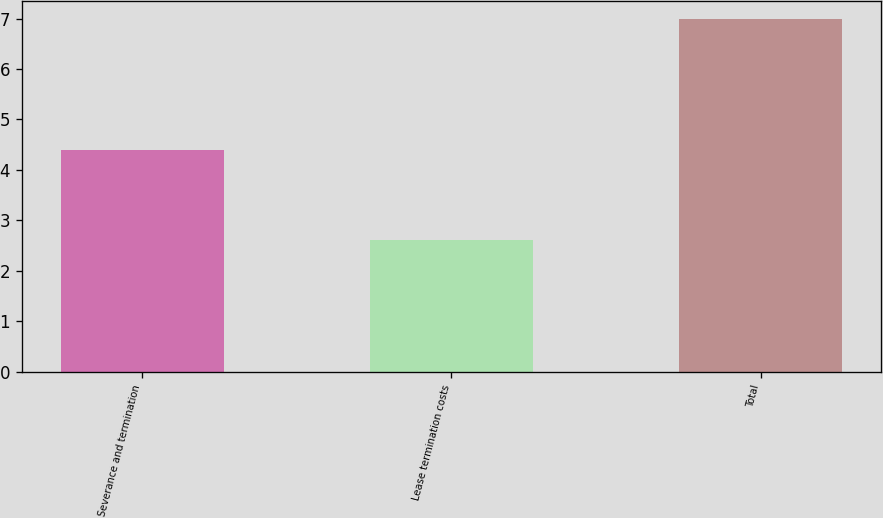<chart> <loc_0><loc_0><loc_500><loc_500><bar_chart><fcel>Severance and termination<fcel>Lease termination costs<fcel>Total<nl><fcel>4.4<fcel>2.6<fcel>7<nl></chart> 